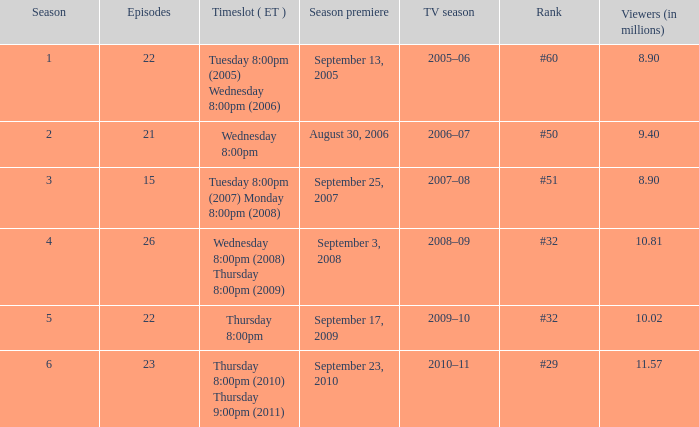What tv season was episode 23 broadcast? 2010–11. 